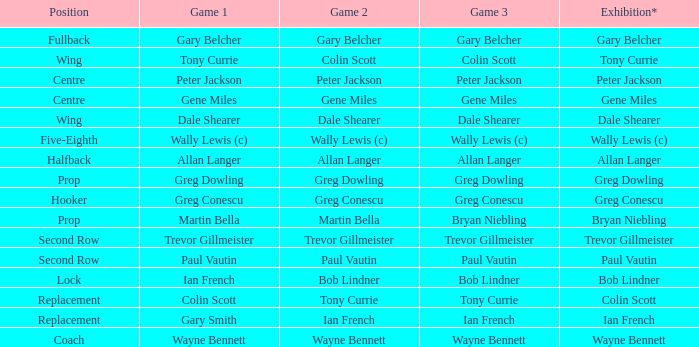What game 1 has halfback as a position? Allan Langer. 